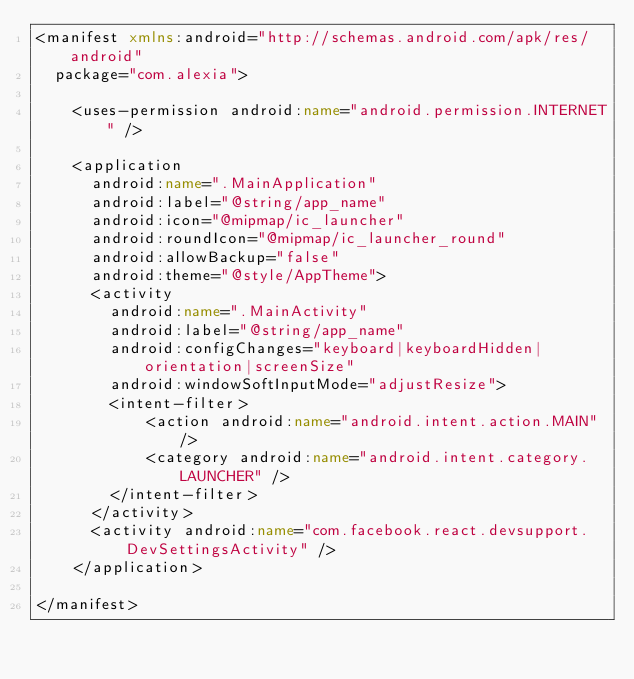<code> <loc_0><loc_0><loc_500><loc_500><_XML_><manifest xmlns:android="http://schemas.android.com/apk/res/android"
  package="com.alexia">

    <uses-permission android:name="android.permission.INTERNET" />

    <application
      android:name=".MainApplication"
      android:label="@string/app_name"
      android:icon="@mipmap/ic_launcher"
      android:roundIcon="@mipmap/ic_launcher_round"
      android:allowBackup="false"
      android:theme="@style/AppTheme">
      <activity
        android:name=".MainActivity"
        android:label="@string/app_name"
        android:configChanges="keyboard|keyboardHidden|orientation|screenSize"
        android:windowSoftInputMode="adjustResize">
        <intent-filter>
            <action android:name="android.intent.action.MAIN" />
            <category android:name="android.intent.category.LAUNCHER" />
        </intent-filter>
      </activity>
      <activity android:name="com.facebook.react.devsupport.DevSettingsActivity" />
    </application>

</manifest>
</code> 